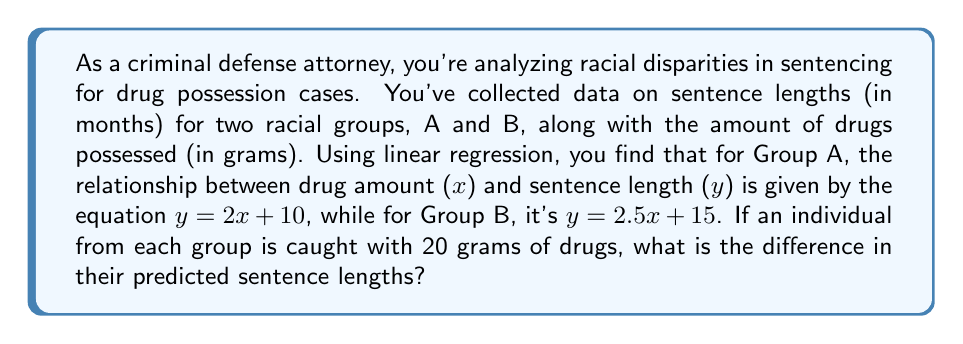Give your solution to this math problem. Let's approach this step-by-step:

1) For Group A, the linear regression equation is:
   $y_A = 2x + 10$

2) For Group B, the linear regression equation is:
   $y_B = 2.5x + 15$

3) We need to calculate the predicted sentence length for each group when x = 20 grams:

   For Group A:
   $y_A = 2(20) + 10 = 40 + 10 = 50$ months

   For Group B:
   $y_B = 2.5(20) + 15 = 50 + 15 = 65$ months

4) To find the difference, we subtract the sentence length for Group A from Group B:

   Difference = $y_B - y_A = 65 - 50 = 15$ months

This difference indicates a racial disparity in sentencing, with Group B receiving a longer sentence for the same amount of drugs possessed.
Answer: 15 months 